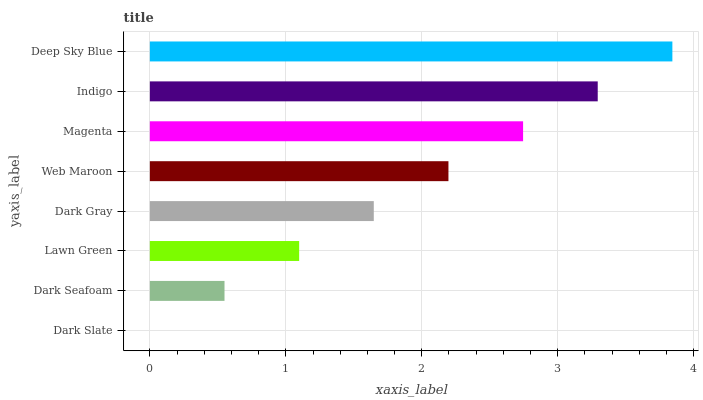Is Dark Slate the minimum?
Answer yes or no. Yes. Is Deep Sky Blue the maximum?
Answer yes or no. Yes. Is Dark Seafoam the minimum?
Answer yes or no. No. Is Dark Seafoam the maximum?
Answer yes or no. No. Is Dark Seafoam greater than Dark Slate?
Answer yes or no. Yes. Is Dark Slate less than Dark Seafoam?
Answer yes or no. Yes. Is Dark Slate greater than Dark Seafoam?
Answer yes or no. No. Is Dark Seafoam less than Dark Slate?
Answer yes or no. No. Is Web Maroon the high median?
Answer yes or no. Yes. Is Dark Gray the low median?
Answer yes or no. Yes. Is Dark Seafoam the high median?
Answer yes or no. No. Is Lawn Green the low median?
Answer yes or no. No. 